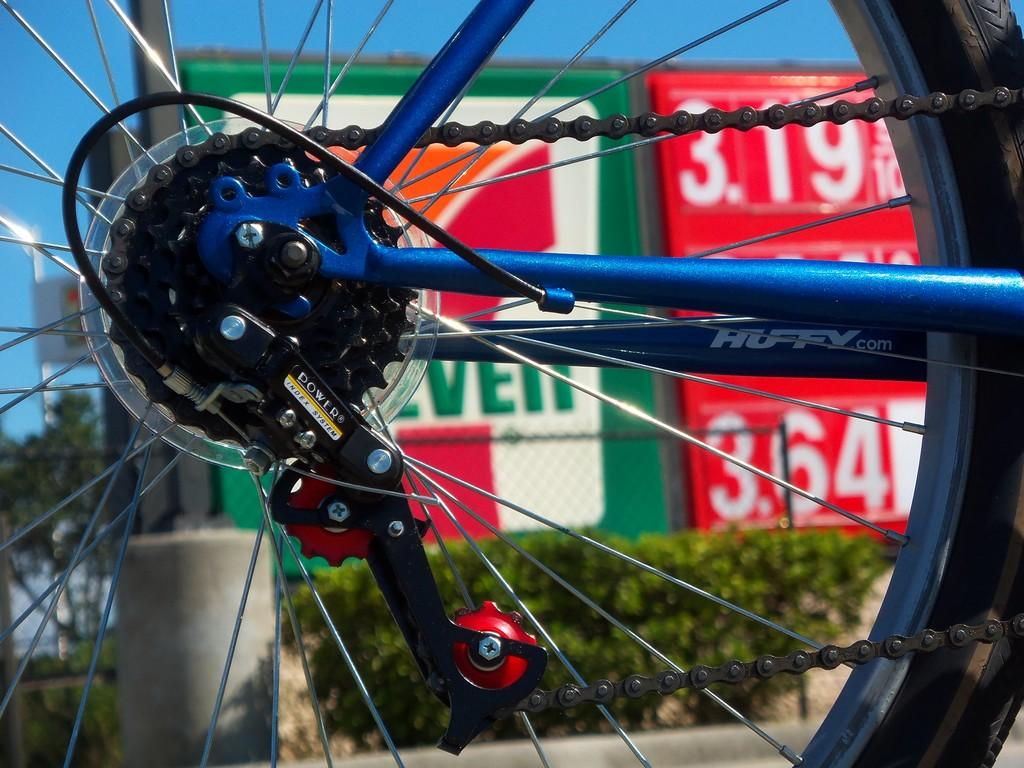What object related to a bicycle can be seen in the image? There is a spare part of a bicycle in the image. What type of natural environment is present in the image? There are trees in the image. What is visible in the background of the image? The sky is visible in the image. How does the friend feel about the attraction in the image? There is no friend or attraction present in the image; it only features a spare part of a bicycle, trees, and the sky. 